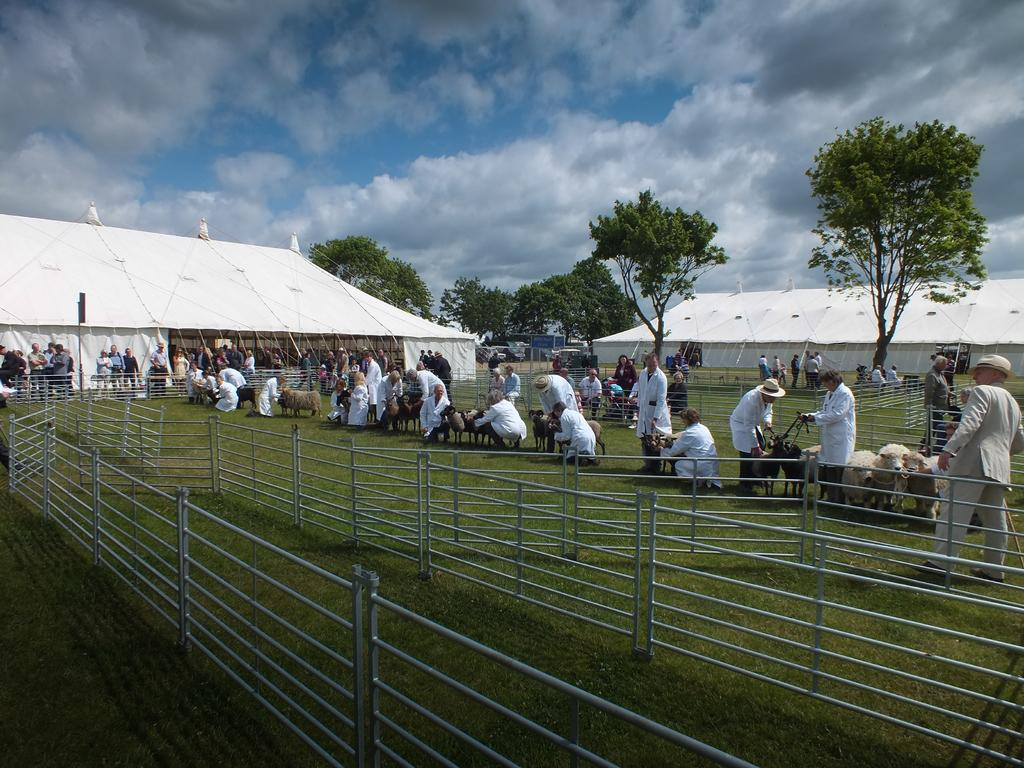What type of surface is visible in the image? There is a ground in the image. What type of vegetation is present on the ground? There is grass in the image. Are there any living beings in the image? Yes, there are people and animals in the image. How many tents are visible in the image? There are two tents in the image. What else can be seen in the image besides the ground, grass, people, animals, and tents? There are trees and a sky visible in the image. What type of sign can be seen directing the animals in the image? There is no sign present in the image directing the animals. How many wheels are visible on the ground in the image? There are no wheels visible on the ground in the image. 